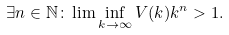Convert formula to latex. <formula><loc_0><loc_0><loc_500><loc_500>\exists n \in \mathbb { N } \colon \lim \inf _ { k \rightarrow \infty } V ( k ) k ^ { n } > 1 .</formula> 